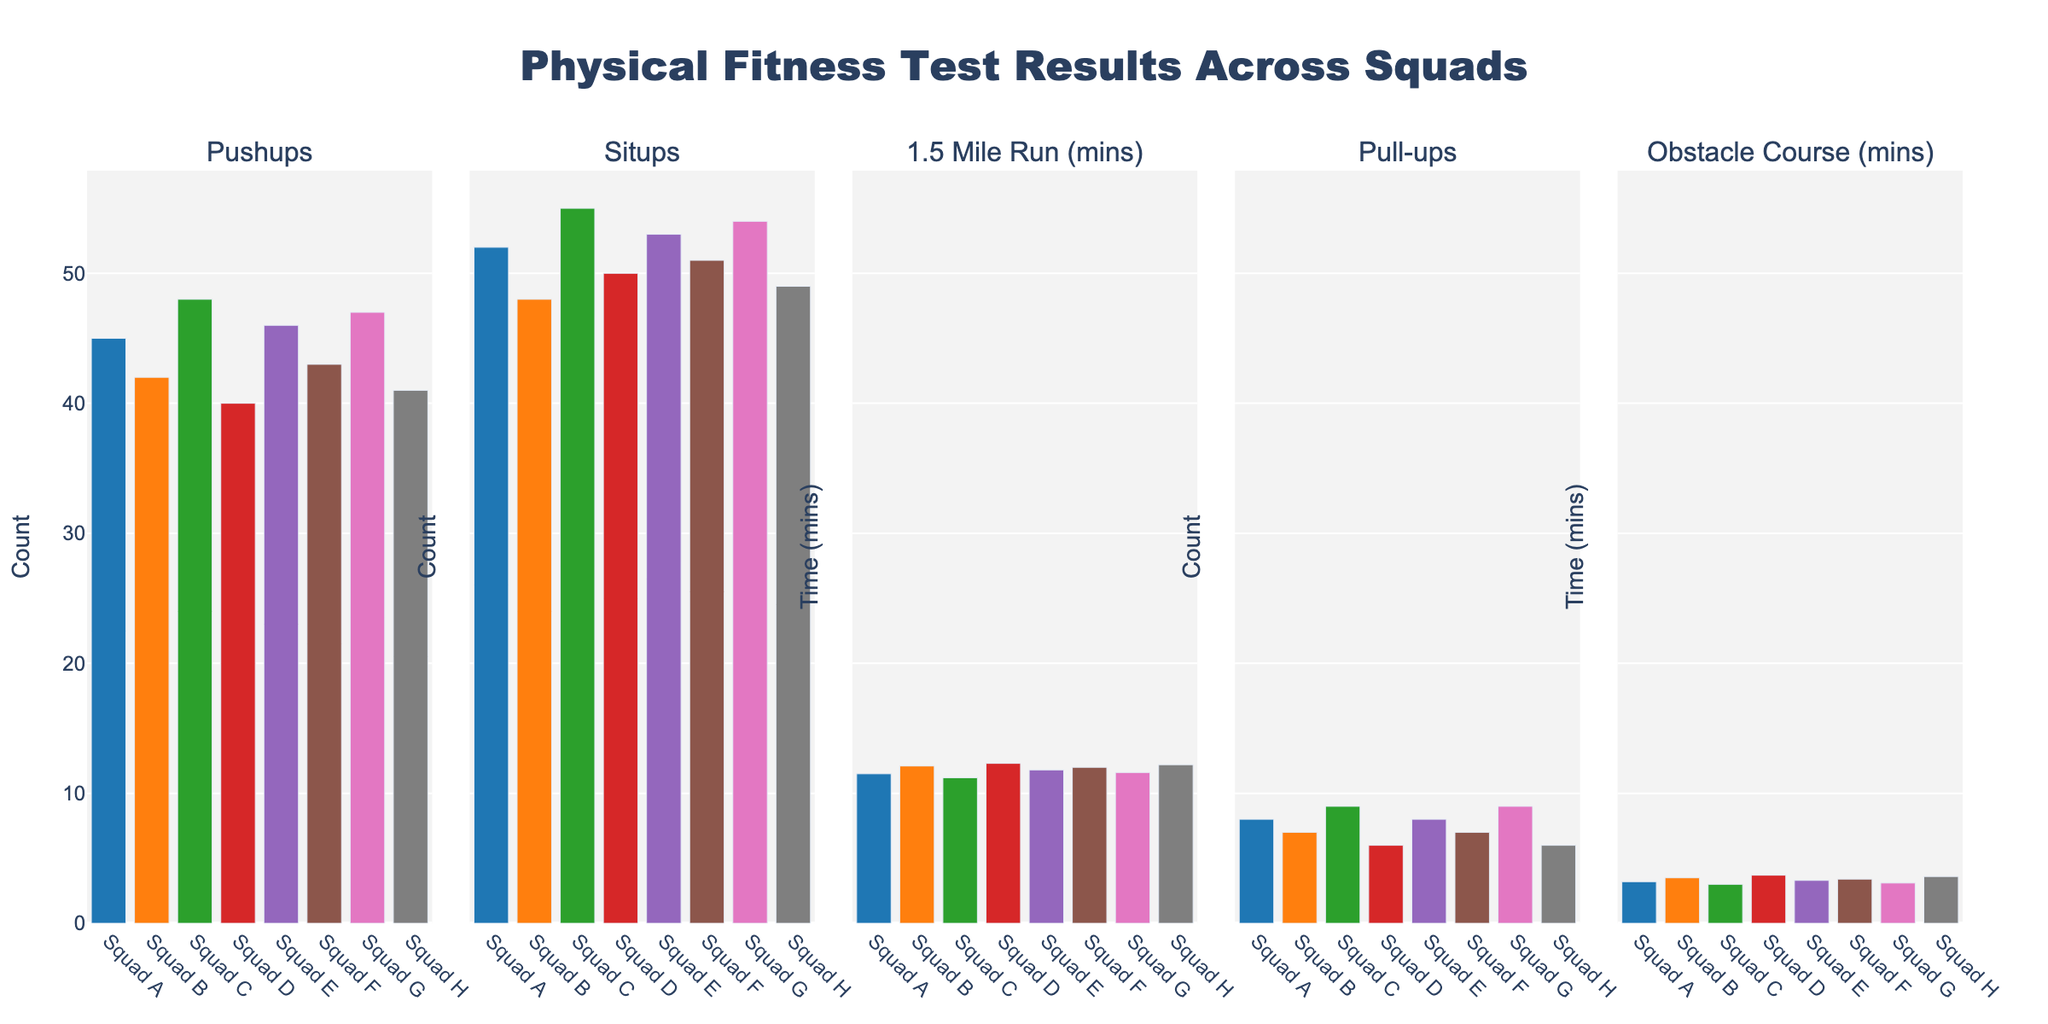Which squad has the highest number of pushups? First, locate the 'Pushups' subplot. Then, visually compare the height of the bars. Squad C has the tallest bar, indicating the highest number of pushups.
Answer: Squad C What is the average time for the 1.5 Mile Run across all squads? First, locate the '1.5 Mile Run (mins)' subplot. Note down the time values: 11.5, 12.1, 11.2, 12.3, 11.8, 12.0, 11.6, and 12.2. Sum these times (11.5 + 12.1 + 11.2 + 12.3 + 11.8 + 12.0 + 11.6 + 12.2 = 94.7). Divide by the number of squads (94.7 / 8 = 11.8375). The average time is approximately 11.84 minutes.
Answer: 11.84 How many more pull-ups did Squad C perform compared to Squad D? First, locate the 'Pull-ups' subplot. Note down the values for Squad C and Squad D which are 9 and 6, respectively. Calculate the difference (9 - 6 = 3).
Answer: 3 Which squad has the lowest obstacle course time? First, locate the 'Obstacle Course (mins)' subplot. Then, visually compare the height of the bars. Squad C has the shortest bar, indicating the lowest obstacle course time.
Answer: Squad C Which exercise did Squad A score the highest in? Identify the values for Squad A across all subplots (45 for Pushups, 52 for Situps, 11.5 mins for 1.5 Mile Run, 8 for Pull-ups, and 3.2 mins for Obstacle Course). Since lower is better for the run and obstacle times, compare the highest values in the others. Squad A scored highest in Situps with 52.
Answer: Situps What is the total number of situps performed by Squad B and Squad F combined? First, find the situps values for Squad B and Squad F which are 48 and 51, respectively. Sum these values (48 + 51 = 99).
Answer: 99 Is the average number of pushups greater than the average number of situps? First, calculate the average pushups by summing the pushups values and dividing by the number of squads: (45 + 42 + 48 + 40 + 46 + 43 + 47 + 41)/8 = 352/8 = 44. Then, calculate the average situps similarly: (52 + 48 + 55 + 50 + 53 + 51 + 54 + 49)/8 = 412/8 = 51.5. Compare the two averages: 44 < 51.5, so the average number of pushups is not greater than the average number of situps.
Answer: No Which squad has the greatest difference between their 1.5 Mile Run time and Obstacle Course time? For each squad, subtract the Obstacle Course time from the 1.5 Mile Run time: Squad A (11.5 - 3.2 = 8.3), Squad B (12.1 - 3.5 = 8.6), Squad C (11.2 - 3.0 = 8.2), Squad D (12.3 - 3.7 = 8.6), Squad E (11.8 - 3.3 = 8.5), Squad F (12.0 - 3.4 = 8.6), Squad G (11.6 - 3.1 = 8.5), Squad H (12.2 - 3.6 = 8.6). The maximum difference is 8.6, seen in Squad B, D, F, and H. To narrow it down, since the question asks for the greatest difference and multiple squads share the greatest value, stating any one correctly yields the answer.
Answer: Squad B (also acceptable: Squad D, Squad F, Squad H) Which two squads have the closest performance in situps? First, list the situp values: Squad A (52), Squad B (48), Squad C (55), Squad D (50), Squad E (53), Squad F (51), Squad G (54), Squad H (49). Calculate the differences between adjacent squads: (52-48=4), (55-50=5), (53-51=2), (54-49=5). The minimum difference is 2, between Squad E and Squad F.
Answer: Squad E and Squad F What is the average number of pull-ups performed by squads C and G? First, locate the pull-up values for squads C and G which are 9 and 9, respectively. Sum and divide by 2 ((9 + 9) / 2 = 9).
Answer: 9 